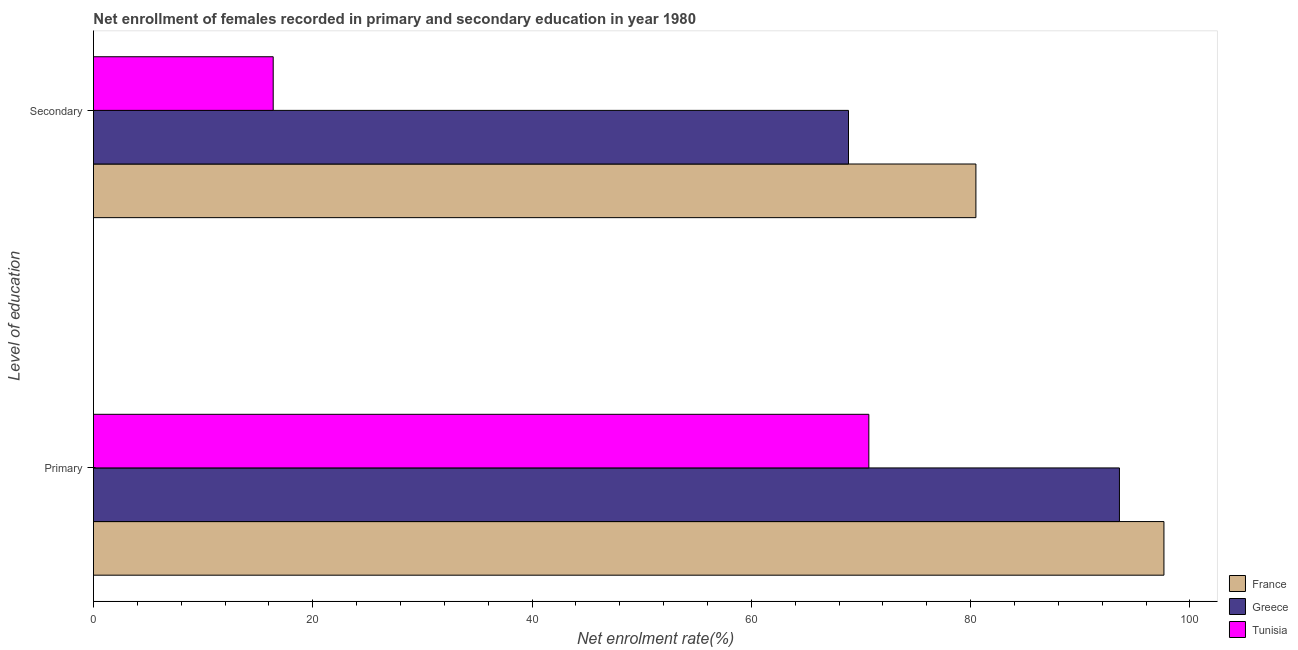How many groups of bars are there?
Provide a short and direct response. 2. Are the number of bars on each tick of the Y-axis equal?
Make the answer very short. Yes. How many bars are there on the 2nd tick from the top?
Give a very brief answer. 3. How many bars are there on the 1st tick from the bottom?
Offer a very short reply. 3. What is the label of the 2nd group of bars from the top?
Give a very brief answer. Primary. What is the enrollment rate in secondary education in Tunisia?
Make the answer very short. 16.39. Across all countries, what is the maximum enrollment rate in secondary education?
Make the answer very short. 80.48. Across all countries, what is the minimum enrollment rate in primary education?
Keep it short and to the point. 70.72. In which country was the enrollment rate in primary education maximum?
Your response must be concise. France. In which country was the enrollment rate in secondary education minimum?
Make the answer very short. Tunisia. What is the total enrollment rate in primary education in the graph?
Provide a succinct answer. 261.92. What is the difference between the enrollment rate in secondary education in Tunisia and that in Greece?
Make the answer very short. -52.47. What is the difference between the enrollment rate in secondary education in Greece and the enrollment rate in primary education in France?
Your answer should be compact. -28.77. What is the average enrollment rate in primary education per country?
Offer a very short reply. 87.31. What is the difference between the enrollment rate in primary education and enrollment rate in secondary education in France?
Provide a short and direct response. 17.15. What is the ratio of the enrollment rate in secondary education in Greece to that in Tunisia?
Make the answer very short. 4.2. Is the enrollment rate in secondary education in France less than that in Greece?
Offer a very short reply. No. In how many countries, is the enrollment rate in secondary education greater than the average enrollment rate in secondary education taken over all countries?
Offer a very short reply. 2. How many bars are there?
Make the answer very short. 6. Are all the bars in the graph horizontal?
Provide a succinct answer. Yes. What is the difference between two consecutive major ticks on the X-axis?
Keep it short and to the point. 20. Does the graph contain any zero values?
Keep it short and to the point. No. Does the graph contain grids?
Provide a succinct answer. No. Where does the legend appear in the graph?
Keep it short and to the point. Bottom right. What is the title of the graph?
Provide a short and direct response. Net enrollment of females recorded in primary and secondary education in year 1980. Does "Panama" appear as one of the legend labels in the graph?
Give a very brief answer. No. What is the label or title of the X-axis?
Provide a succinct answer. Net enrolment rate(%). What is the label or title of the Y-axis?
Make the answer very short. Level of education. What is the Net enrolment rate(%) in France in Primary?
Offer a terse response. 97.63. What is the Net enrolment rate(%) of Greece in Primary?
Make the answer very short. 93.57. What is the Net enrolment rate(%) in Tunisia in Primary?
Offer a very short reply. 70.72. What is the Net enrolment rate(%) of France in Secondary?
Keep it short and to the point. 80.48. What is the Net enrolment rate(%) in Greece in Secondary?
Provide a short and direct response. 68.86. What is the Net enrolment rate(%) of Tunisia in Secondary?
Provide a succinct answer. 16.39. Across all Level of education, what is the maximum Net enrolment rate(%) of France?
Offer a very short reply. 97.63. Across all Level of education, what is the maximum Net enrolment rate(%) of Greece?
Make the answer very short. 93.57. Across all Level of education, what is the maximum Net enrolment rate(%) of Tunisia?
Your answer should be compact. 70.72. Across all Level of education, what is the minimum Net enrolment rate(%) of France?
Provide a short and direct response. 80.48. Across all Level of education, what is the minimum Net enrolment rate(%) in Greece?
Give a very brief answer. 68.86. Across all Level of education, what is the minimum Net enrolment rate(%) in Tunisia?
Your answer should be very brief. 16.39. What is the total Net enrolment rate(%) in France in the graph?
Provide a short and direct response. 178.12. What is the total Net enrolment rate(%) of Greece in the graph?
Ensure brevity in your answer.  162.44. What is the total Net enrolment rate(%) of Tunisia in the graph?
Your answer should be compact. 87.11. What is the difference between the Net enrolment rate(%) of France in Primary and that in Secondary?
Keep it short and to the point. 17.15. What is the difference between the Net enrolment rate(%) of Greece in Primary and that in Secondary?
Your answer should be compact. 24.71. What is the difference between the Net enrolment rate(%) in Tunisia in Primary and that in Secondary?
Provide a short and direct response. 54.33. What is the difference between the Net enrolment rate(%) of France in Primary and the Net enrolment rate(%) of Greece in Secondary?
Your answer should be compact. 28.77. What is the difference between the Net enrolment rate(%) of France in Primary and the Net enrolment rate(%) of Tunisia in Secondary?
Provide a short and direct response. 81.24. What is the difference between the Net enrolment rate(%) of Greece in Primary and the Net enrolment rate(%) of Tunisia in Secondary?
Offer a terse response. 77.18. What is the average Net enrolment rate(%) of France per Level of education?
Keep it short and to the point. 89.06. What is the average Net enrolment rate(%) in Greece per Level of education?
Your answer should be very brief. 81.22. What is the average Net enrolment rate(%) of Tunisia per Level of education?
Your answer should be compact. 43.56. What is the difference between the Net enrolment rate(%) of France and Net enrolment rate(%) of Greece in Primary?
Keep it short and to the point. 4.06. What is the difference between the Net enrolment rate(%) in France and Net enrolment rate(%) in Tunisia in Primary?
Ensure brevity in your answer.  26.91. What is the difference between the Net enrolment rate(%) of Greece and Net enrolment rate(%) of Tunisia in Primary?
Offer a very short reply. 22.86. What is the difference between the Net enrolment rate(%) of France and Net enrolment rate(%) of Greece in Secondary?
Your answer should be very brief. 11.62. What is the difference between the Net enrolment rate(%) of France and Net enrolment rate(%) of Tunisia in Secondary?
Make the answer very short. 64.09. What is the difference between the Net enrolment rate(%) of Greece and Net enrolment rate(%) of Tunisia in Secondary?
Offer a terse response. 52.47. What is the ratio of the Net enrolment rate(%) in France in Primary to that in Secondary?
Your answer should be compact. 1.21. What is the ratio of the Net enrolment rate(%) in Greece in Primary to that in Secondary?
Give a very brief answer. 1.36. What is the ratio of the Net enrolment rate(%) in Tunisia in Primary to that in Secondary?
Your response must be concise. 4.31. What is the difference between the highest and the second highest Net enrolment rate(%) in France?
Your answer should be compact. 17.15. What is the difference between the highest and the second highest Net enrolment rate(%) of Greece?
Offer a terse response. 24.71. What is the difference between the highest and the second highest Net enrolment rate(%) in Tunisia?
Provide a succinct answer. 54.33. What is the difference between the highest and the lowest Net enrolment rate(%) in France?
Give a very brief answer. 17.15. What is the difference between the highest and the lowest Net enrolment rate(%) of Greece?
Your answer should be compact. 24.71. What is the difference between the highest and the lowest Net enrolment rate(%) of Tunisia?
Give a very brief answer. 54.33. 